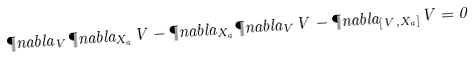Convert formula to latex. <formula><loc_0><loc_0><loc_500><loc_500>\P n a b l a _ { V } \P n a b l a _ { X _ { a } } V - \P n a b l a _ { X _ { a } } \P n a b l a _ { V } V - \P n a b l a _ { [ V , X _ { a } ] } V = 0</formula> 